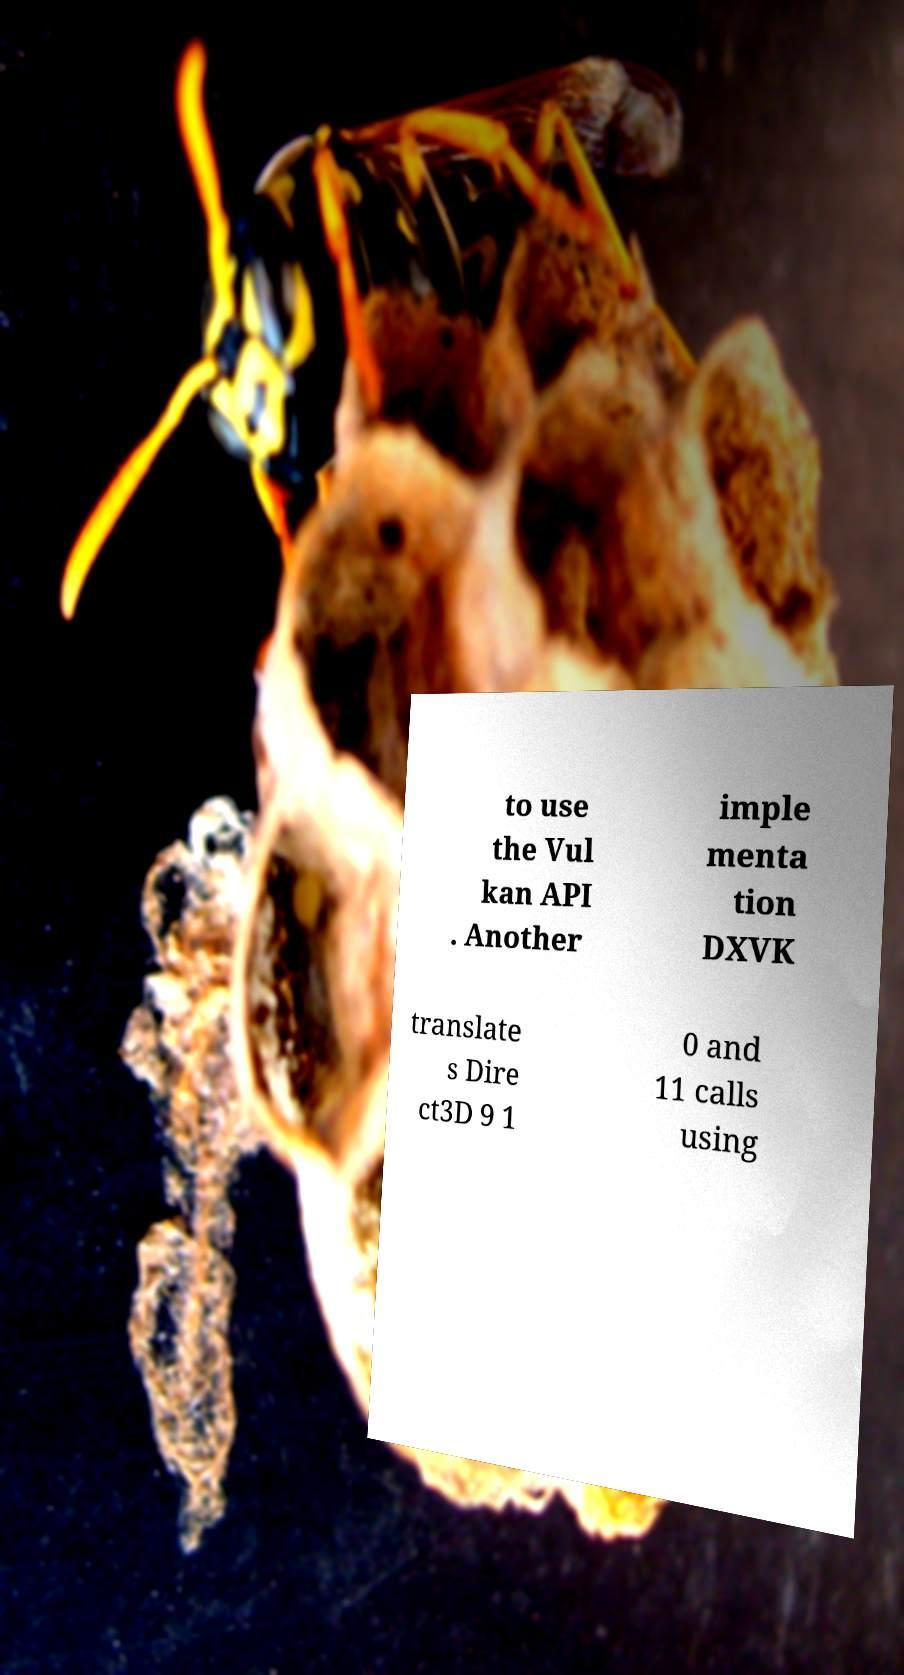Please identify and transcribe the text found in this image. to use the Vul kan API . Another imple menta tion DXVK translate s Dire ct3D 9 1 0 and 11 calls using 